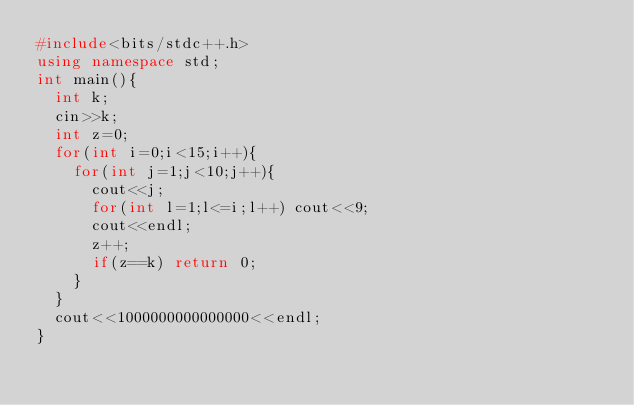<code> <loc_0><loc_0><loc_500><loc_500><_C++_>#include<bits/stdc++.h>
using namespace std;
int main(){
  int k;
  cin>>k;
  int z=0;
  for(int i=0;i<15;i++){
    for(int j=1;j<10;j++){
      cout<<j;
      for(int l=1;l<=i;l++) cout<<9;
      cout<<endl;
      z++;
      if(z==k) return 0;
    }
  }
  cout<<1000000000000000<<endl;
}</code> 